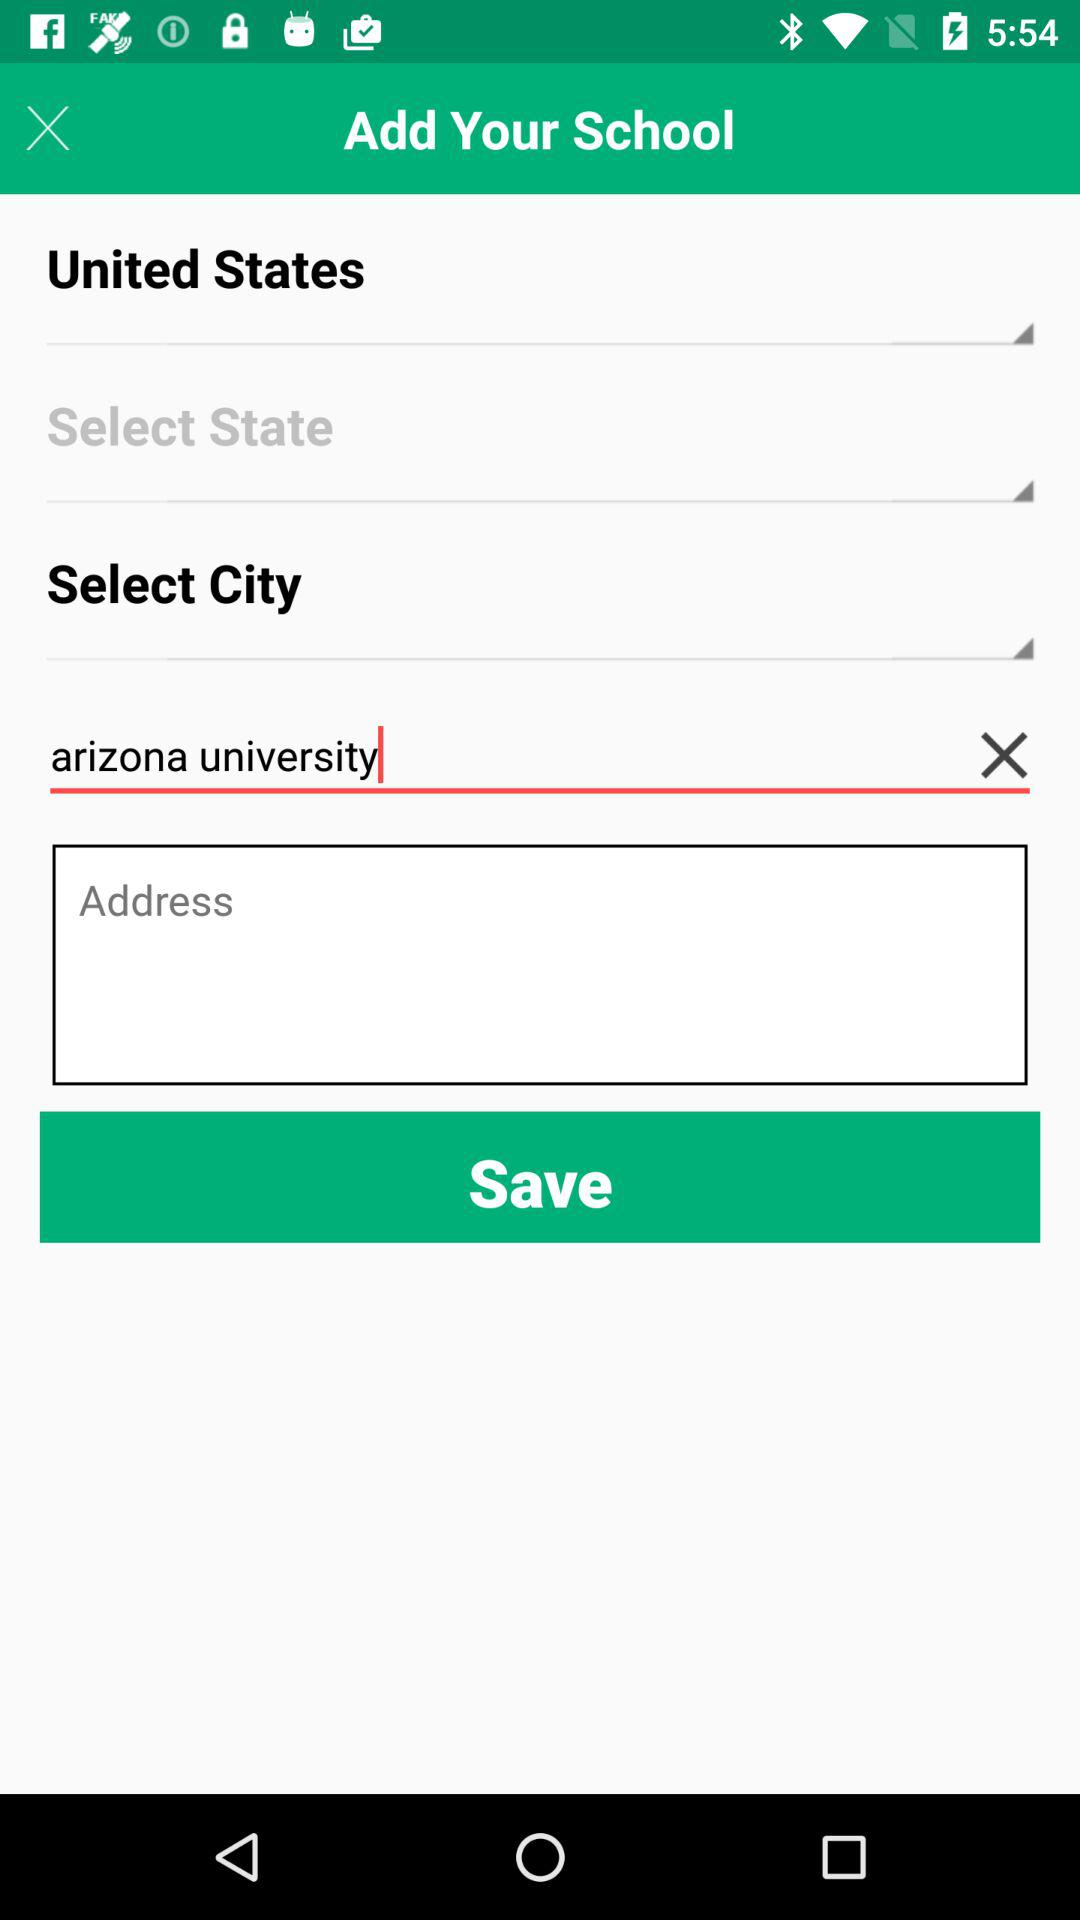Which country is selected? The selected country is the United States. 